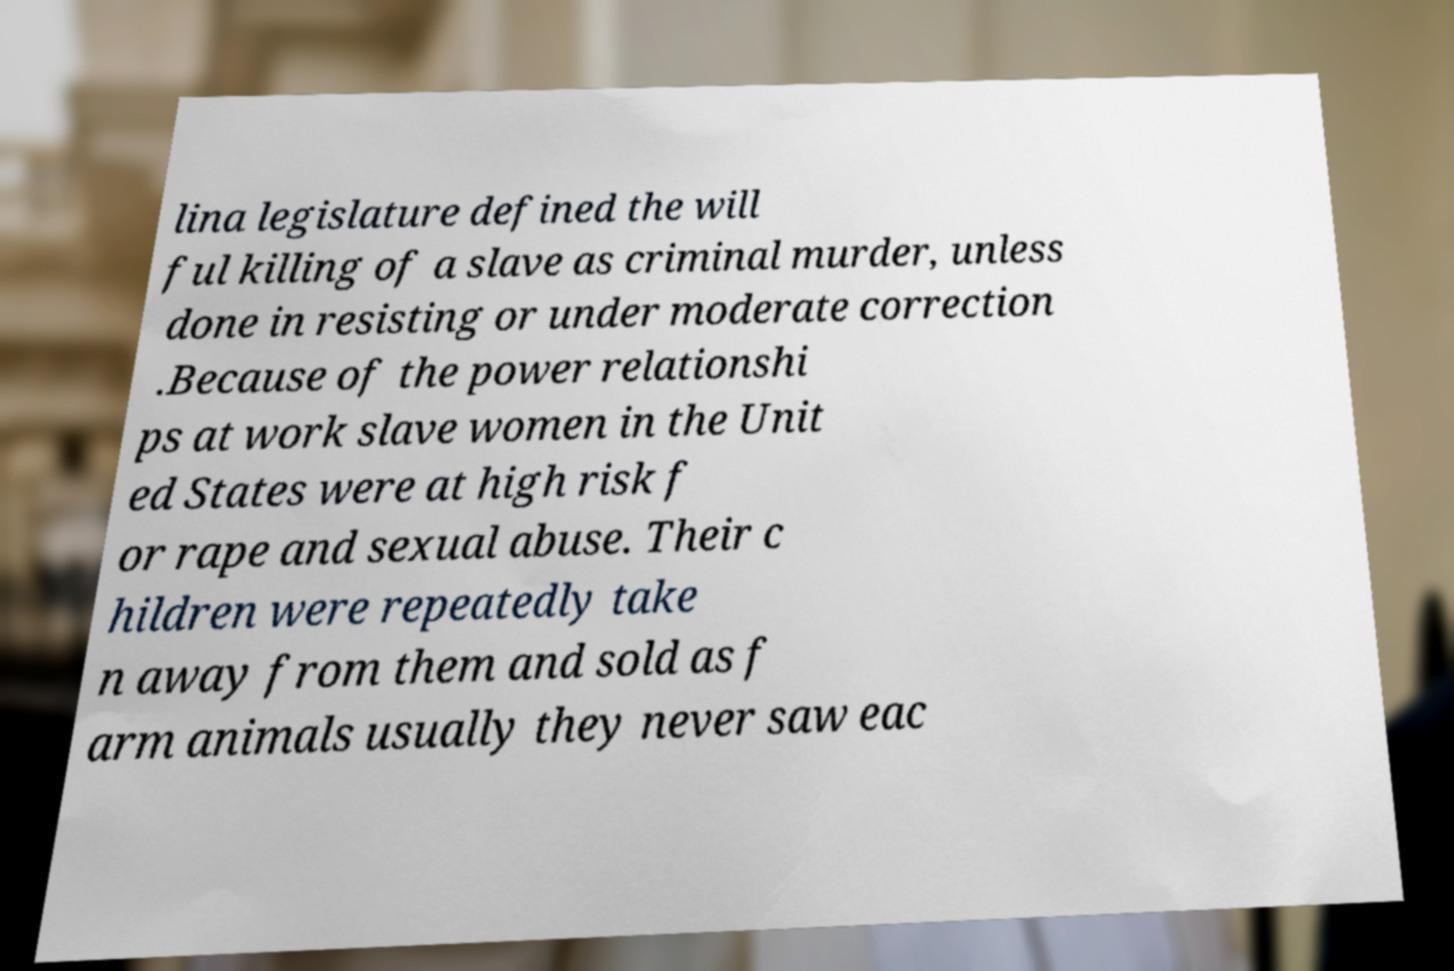Please read and relay the text visible in this image. What does it say? lina legislature defined the will ful killing of a slave as criminal murder, unless done in resisting or under moderate correction .Because of the power relationshi ps at work slave women in the Unit ed States were at high risk f or rape and sexual abuse. Their c hildren were repeatedly take n away from them and sold as f arm animals usually they never saw eac 